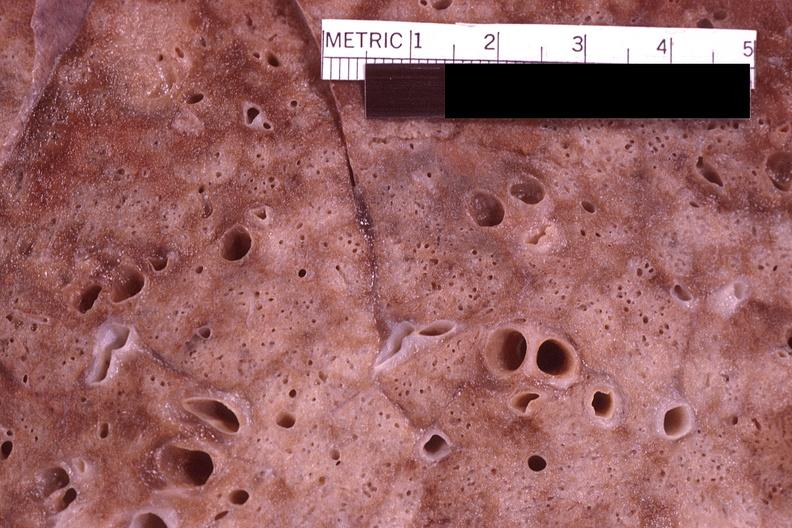s mesothelioma present?
Answer the question using a single word or phrase. No 